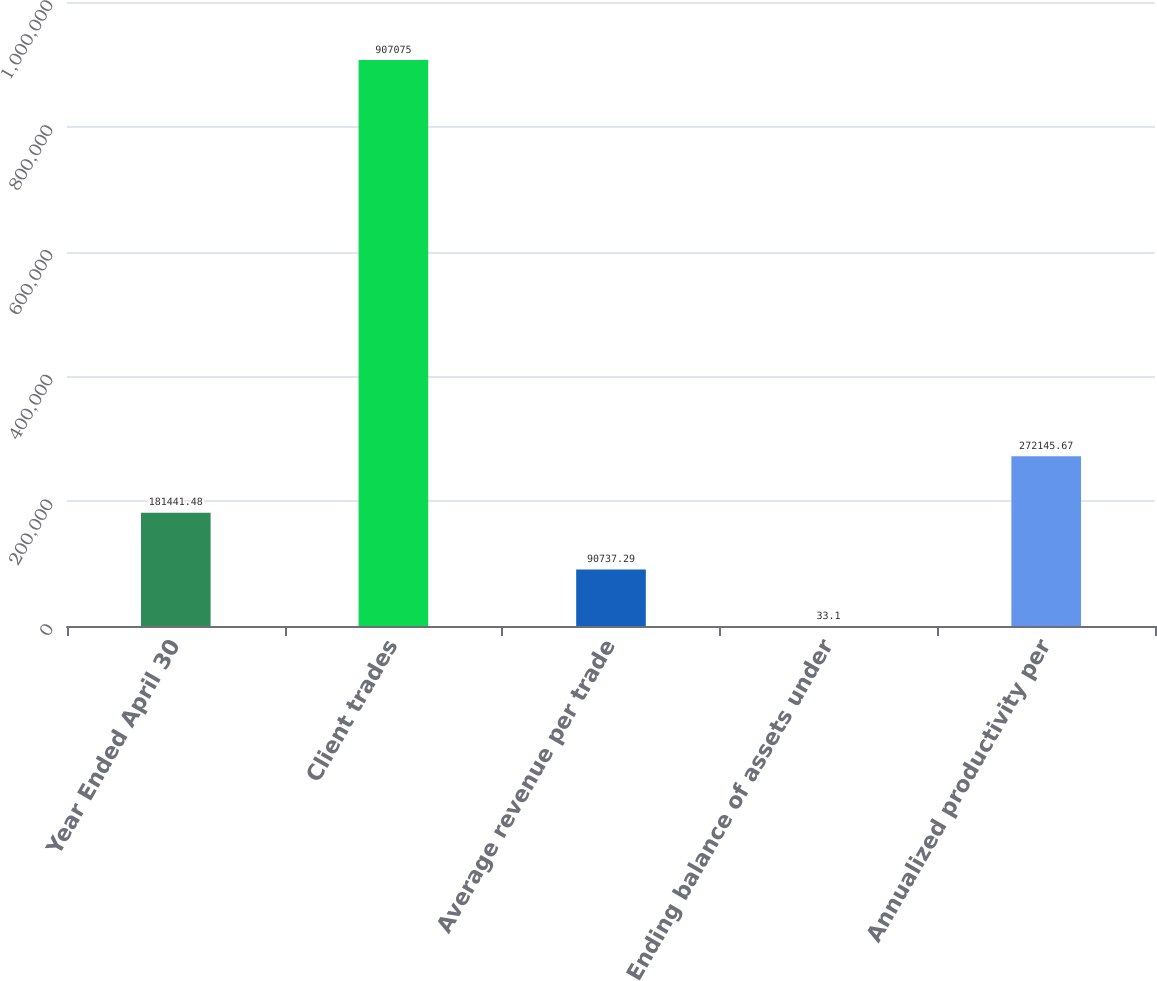Convert chart to OTSL. <chart><loc_0><loc_0><loc_500><loc_500><bar_chart><fcel>Year Ended April 30<fcel>Client trades<fcel>Average revenue per trade<fcel>Ending balance of assets under<fcel>Annualized productivity per<nl><fcel>181441<fcel>907075<fcel>90737.3<fcel>33.1<fcel>272146<nl></chart> 